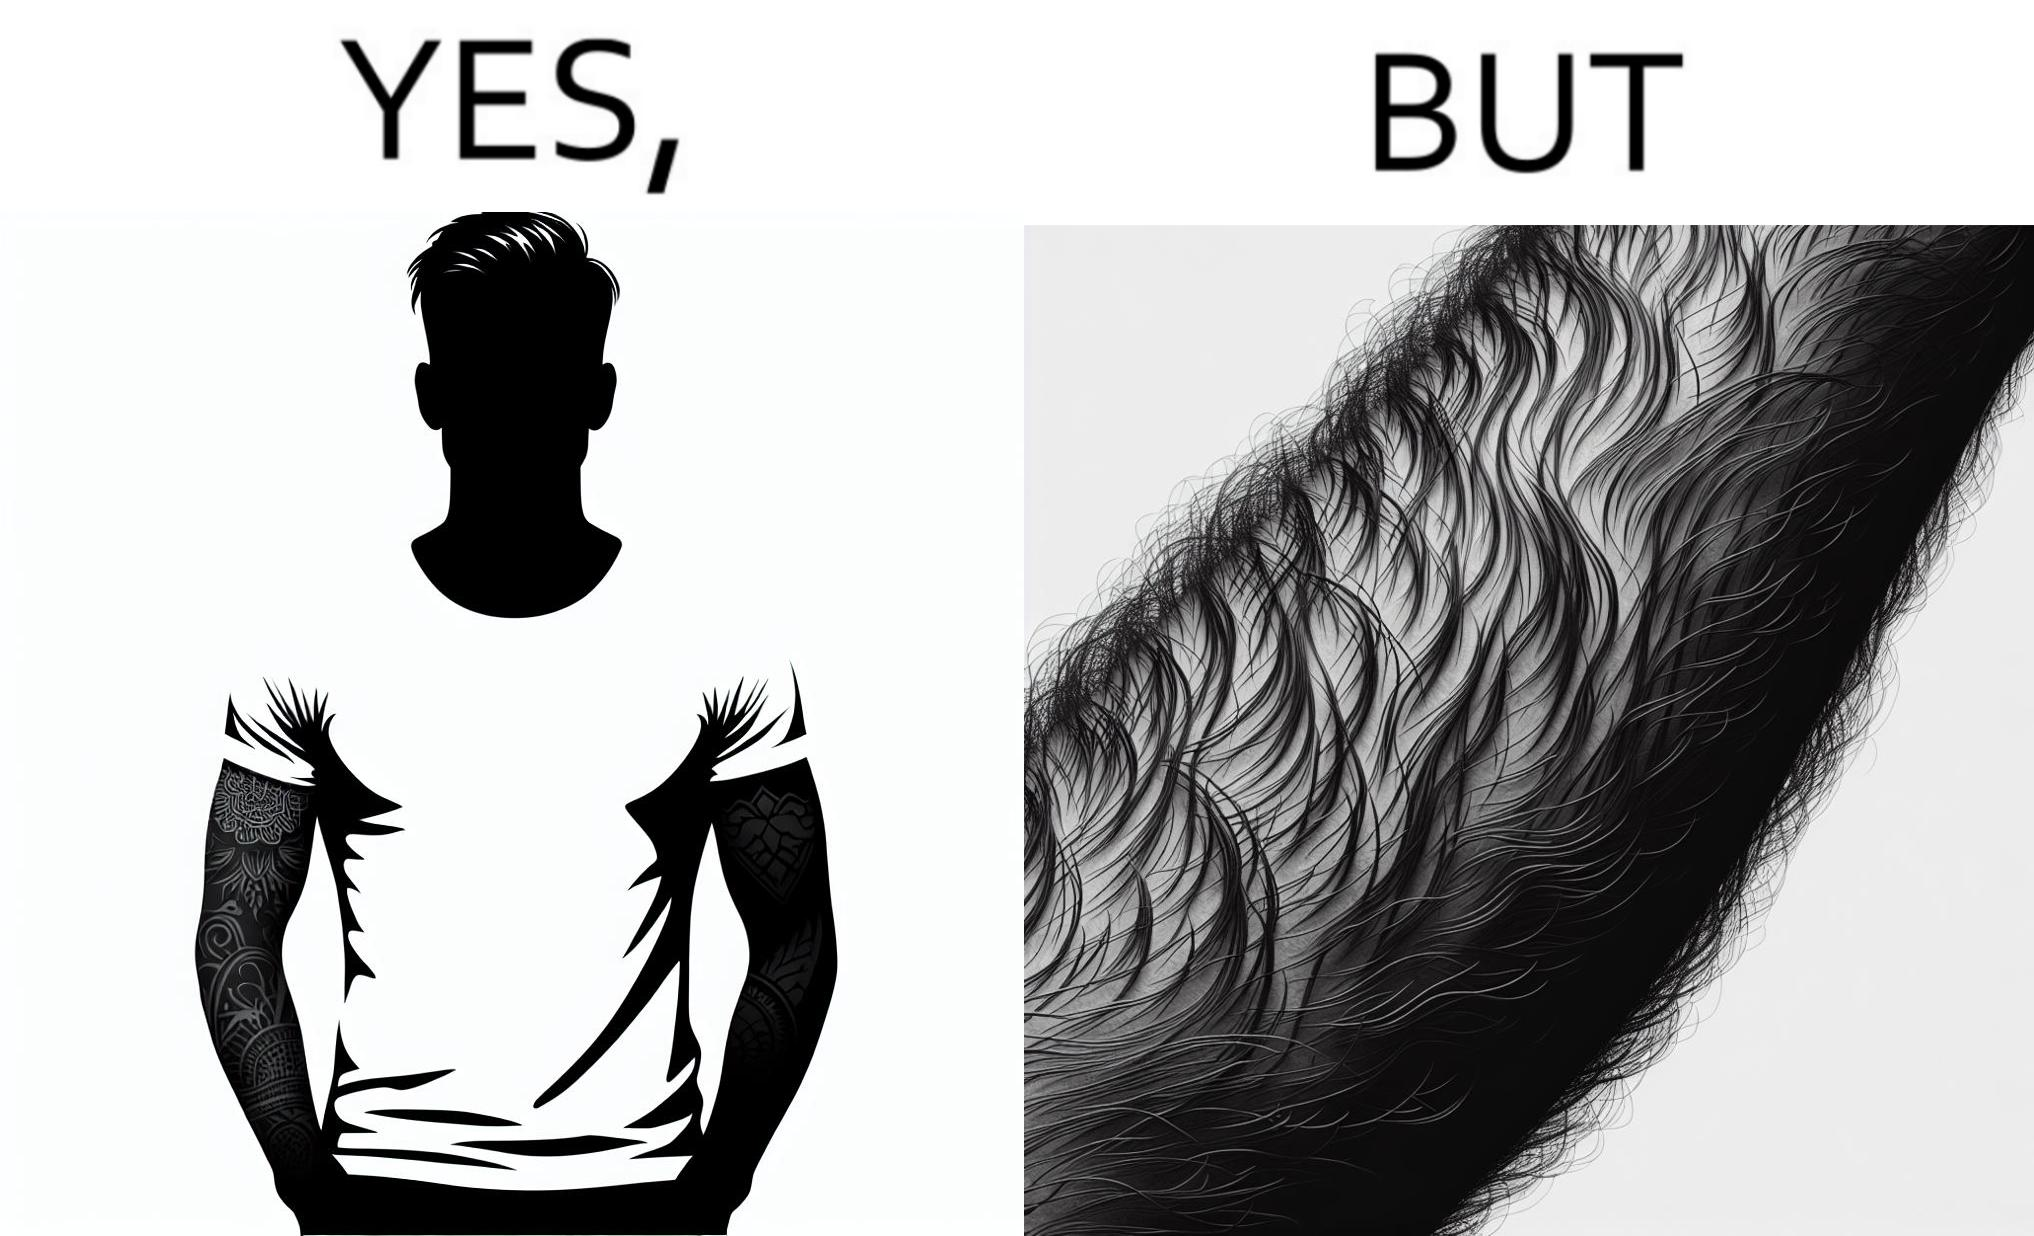Why is this image considered satirical? The image is funny because while from the distance it seems that the man has big tattoos on both of his arms upon a closer look at the arms it turns out there is no tattoo and what seemed to be tattoos are just hairs on his arm. 